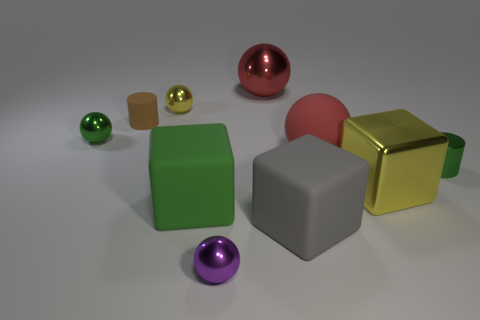There is another ball that is the same color as the big metallic ball; what is it made of?
Give a very brief answer. Rubber. What number of tiny objects are the same color as the big rubber ball?
Your answer should be very brief. 0. There is a tiny rubber object; is its color the same as the big matte cube that is to the left of the purple metallic sphere?
Offer a terse response. No. What number of things are either large green rubber objects or tiny things left of the purple shiny object?
Give a very brief answer. 4. How big is the red thing left of the large red ball in front of the tiny yellow sphere?
Offer a terse response. Large. Are there an equal number of gray cubes that are behind the yellow sphere and yellow metallic objects in front of the big red matte sphere?
Your response must be concise. No. Is there a small purple thing behind the rubber cube that is to the right of the purple ball?
Offer a terse response. No. There is a green thing that is made of the same material as the big gray object; what is its shape?
Your response must be concise. Cube. Is there anything else of the same color as the matte ball?
Provide a short and direct response. Yes. What is the material of the small cylinder that is behind the cylinder that is right of the gray thing?
Your response must be concise. Rubber. 